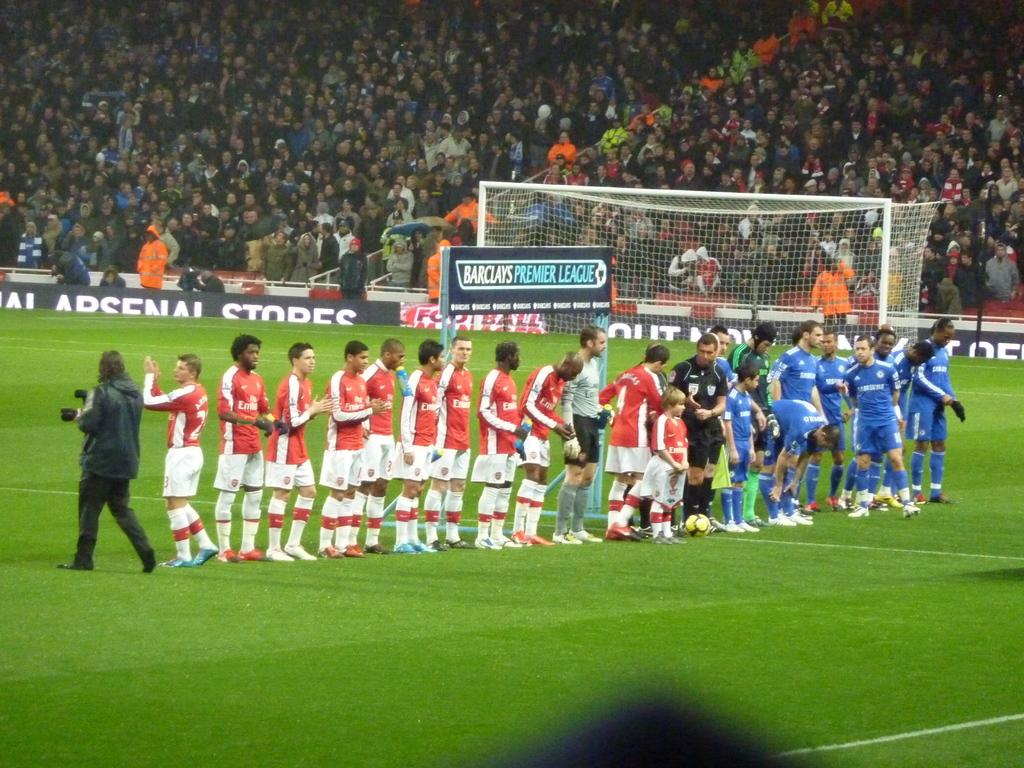<image>
Present a compact description of the photo's key features. Athletes on a field in front of a sign that says Barclay's Premier League. 